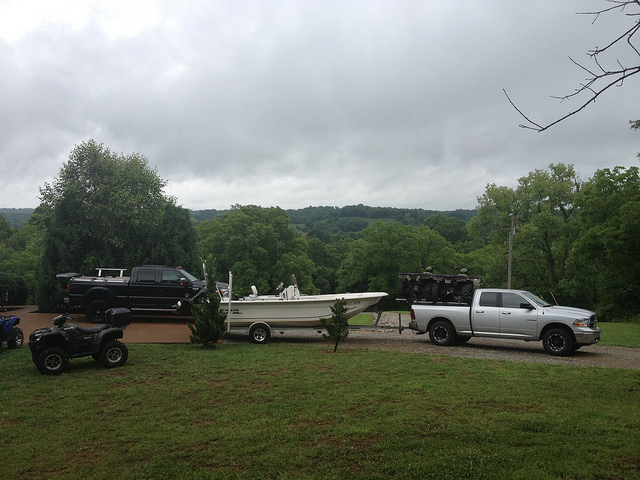<image>Where is the house? There is no house in the image. Where is the house? It is unknown where the house is located. There is no house in the image. 